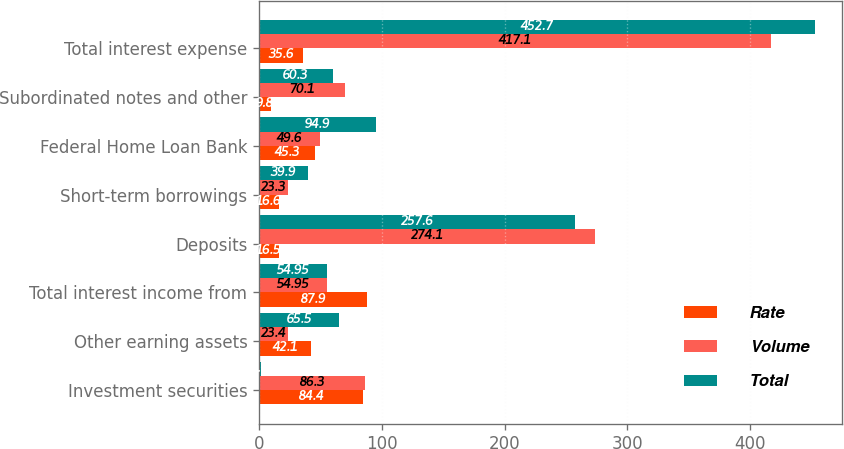Convert chart. <chart><loc_0><loc_0><loc_500><loc_500><stacked_bar_chart><ecel><fcel>Investment securities<fcel>Other earning assets<fcel>Total interest income from<fcel>Deposits<fcel>Short-term borrowings<fcel>Federal Home Loan Bank<fcel>Subordinated notes and other<fcel>Total interest expense<nl><fcel>Rate<fcel>84.4<fcel>42.1<fcel>87.9<fcel>16.5<fcel>16.6<fcel>45.3<fcel>9.8<fcel>35.6<nl><fcel>Volume<fcel>86.3<fcel>23.4<fcel>54.95<fcel>274.1<fcel>23.3<fcel>49.6<fcel>70.1<fcel>417.1<nl><fcel>Total<fcel>1.9<fcel>65.5<fcel>54.95<fcel>257.6<fcel>39.9<fcel>94.9<fcel>60.3<fcel>452.7<nl></chart> 